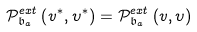Convert formula to latex. <formula><loc_0><loc_0><loc_500><loc_500>\mathcal { P } _ { \mathfrak { b } _ { a } } ^ { e x t } \left ( v ^ { \ast } , \upsilon ^ { \ast } \right ) = \mathcal { P } _ { \mathfrak { b } _ { a } } ^ { e x t } \left ( v , \upsilon \right )</formula> 